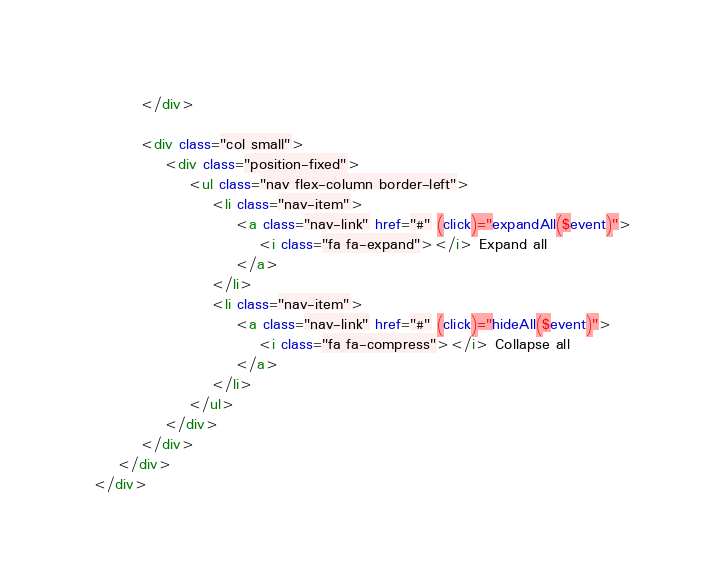Convert code to text. <code><loc_0><loc_0><loc_500><loc_500><_HTML_>        </div>

        <div class="col small">
            <div class="position-fixed">
                <ul class="nav flex-column border-left">
                    <li class="nav-item">
                        <a class="nav-link" href="#" (click)="expandAll($event)">
                            <i class="fa fa-expand"></i> Expand all
                        </a>
                    </li>
                    <li class="nav-item">
                        <a class="nav-link" href="#" (click)="hideAll($event)">
                            <i class="fa fa-compress"></i> Collapse all
                        </a>
                    </li>
                </ul>
            </div>
        </div>
    </div>
</div></code> 